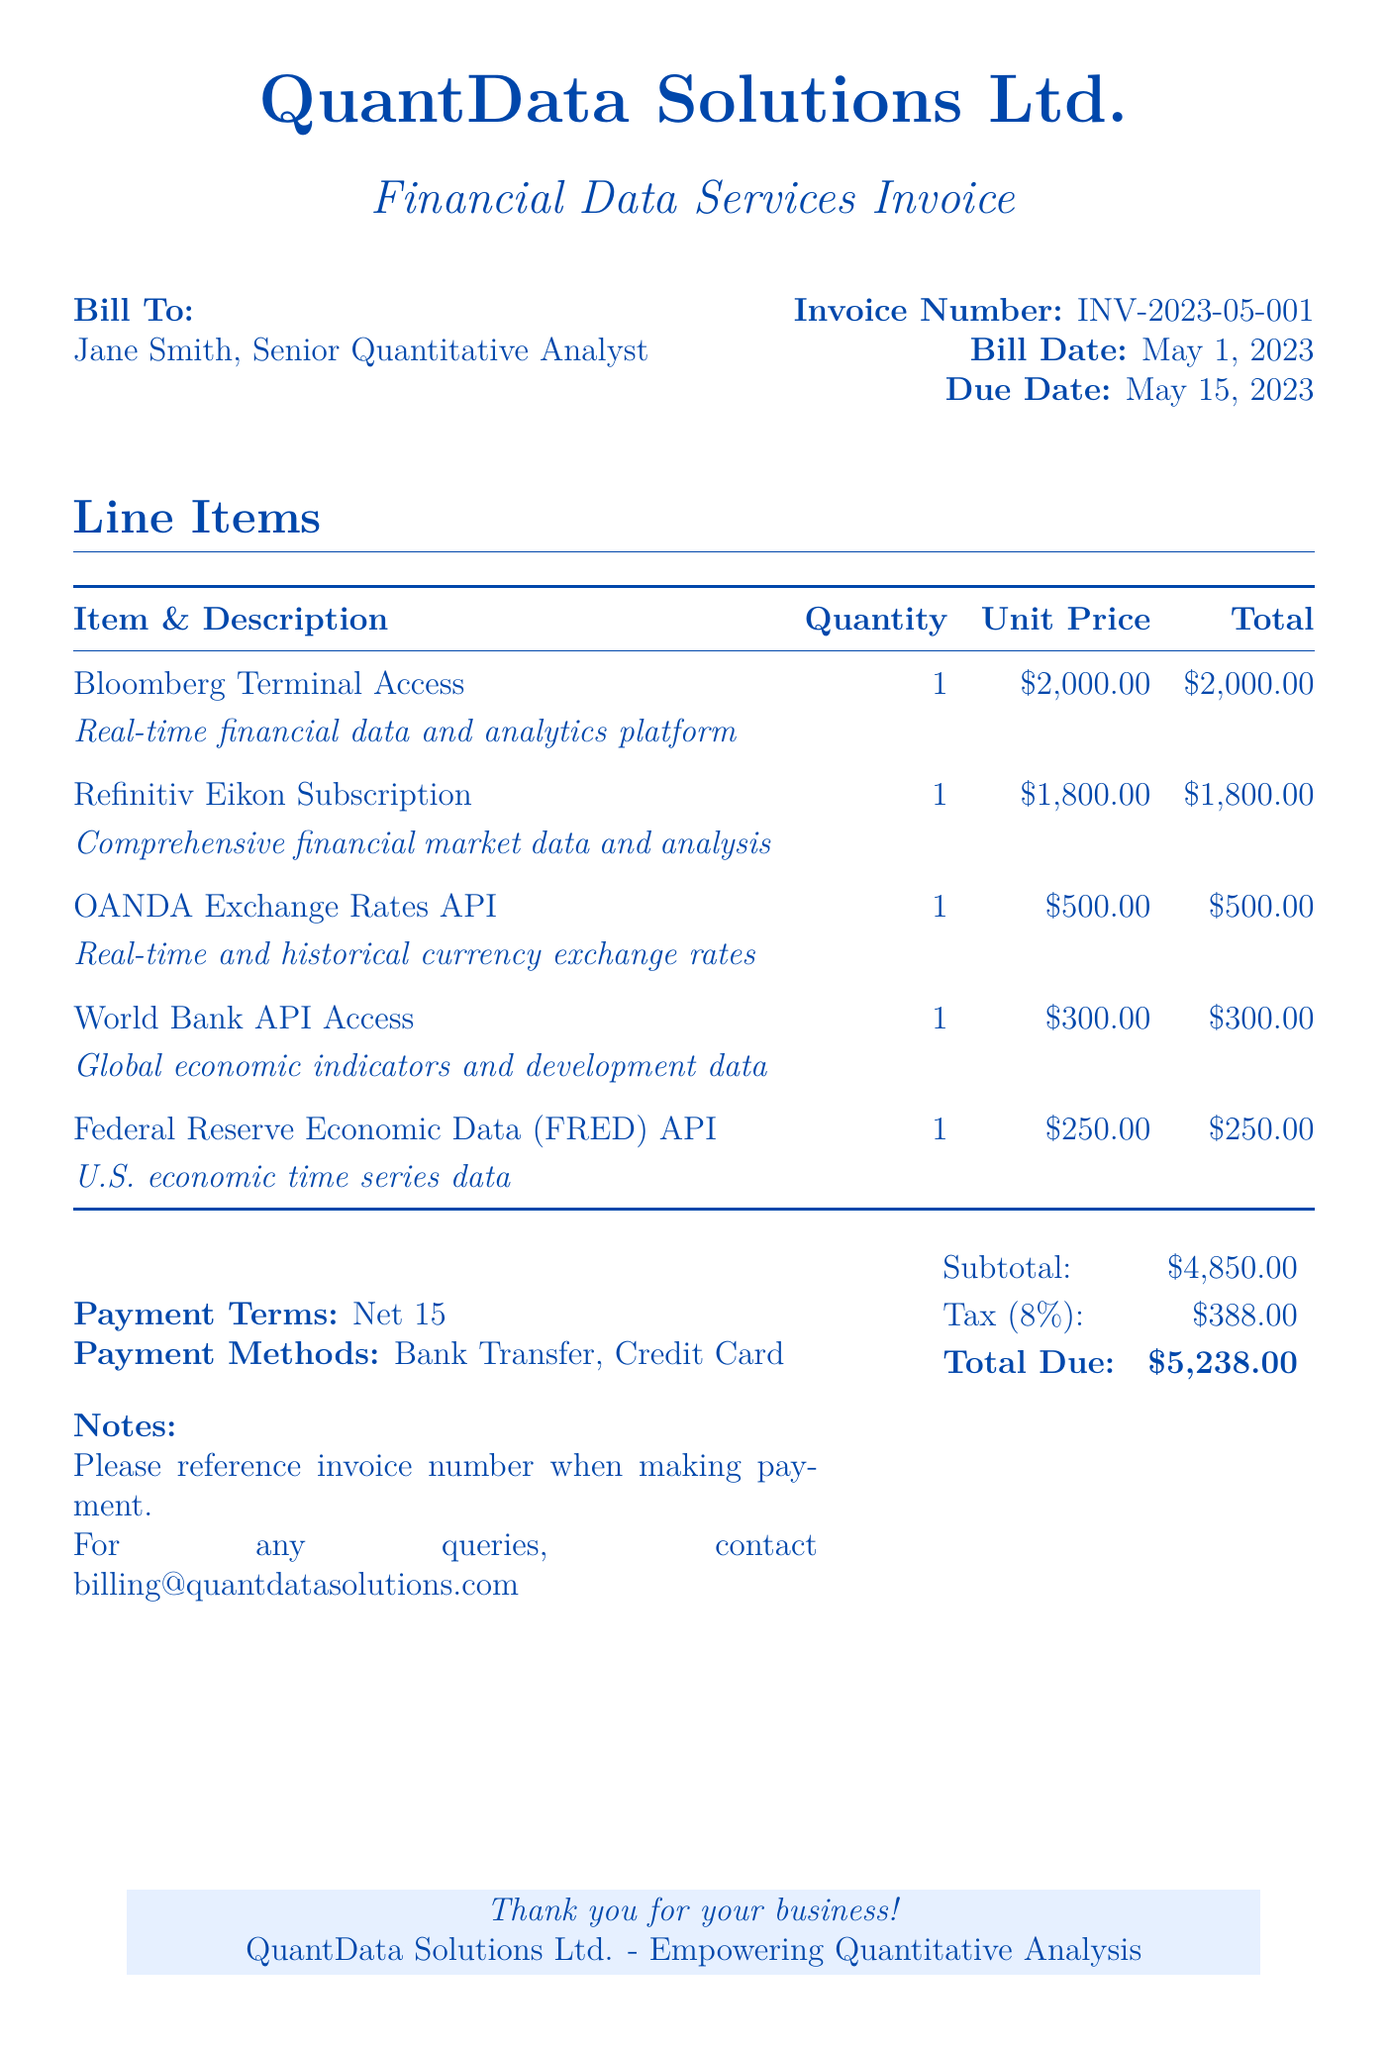What is the invoice number? The invoice number is a unique identifier for the bill issued. It can be found in the 'Invoice Number' section of the document.
Answer: INV-2023-05-001 What is the bill date? The bill date indicates when the invoice was generated. It is stated in the 'Bill Date' section of the document.
Answer: May 1, 2023 What is the total due amount? The total due amount is the final amount owed as per the bill, calculated as subtotal plus tax. This information is presented in bold at the end of the document.
Answer: $5,238.00 How many subscription items are listed? The number of subscription items refers to the distinct services or products charged in the invoice. They can be counted in the line items section.
Answer: 5 Which service has the highest cost? The highest cost service refers to the line item with the greatest unit price. This value can be inferred from the line items provided in the table.
Answer: Bloomberg Terminal Access What is the tax percentage applied? The tax percentage is shown explicitly in the document, indicating how much tax is calculated based on the subtotal.
Answer: 8% What method of payment is accepted? The methods of payment list the acceptable ways for the client to settle the invoice, detailed in the payment methods area of the bill.
Answer: Bank Transfer, Credit Card What is the payment term? The payment term specifies the time frame within which the payment must be made. This term is highlighted in the relevant section of the document.
Answer: Net 15 What economic data is accessed through the World Bank API? The World Bank API grants access to various types of economic indicators, which are briefly described in the line item of the document.
Answer: Global economic indicators and development data 